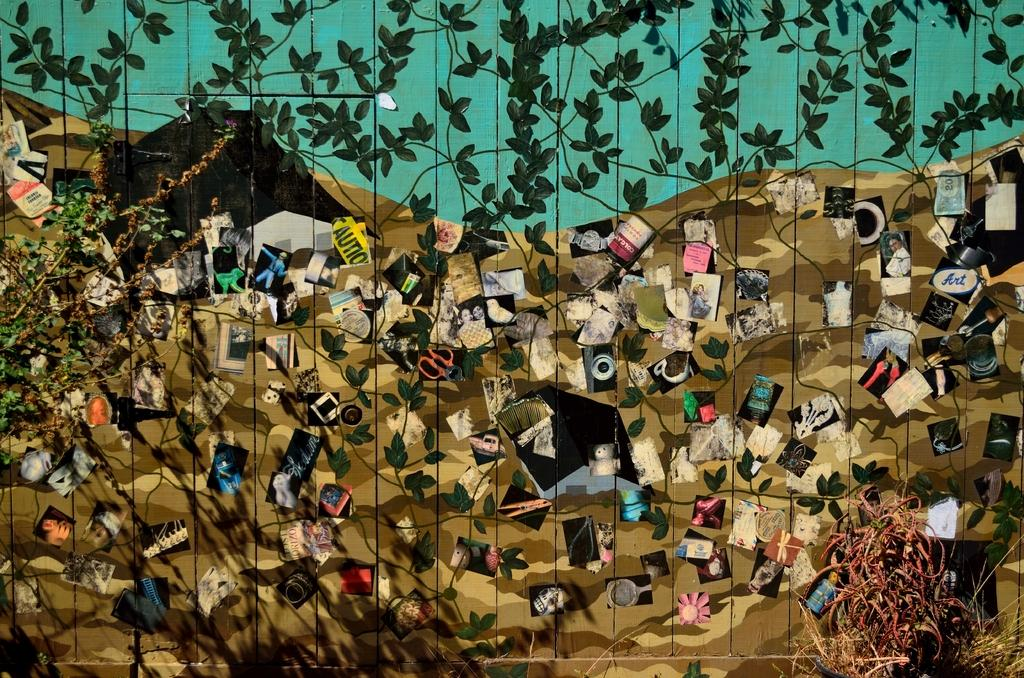What is hanging on the wall in the image? There is a painting on the wall in the image. What type of cork is used to secure the painting to the wall in the image? There is no mention of a cork or any method of securing the painting to the wall in the image. 